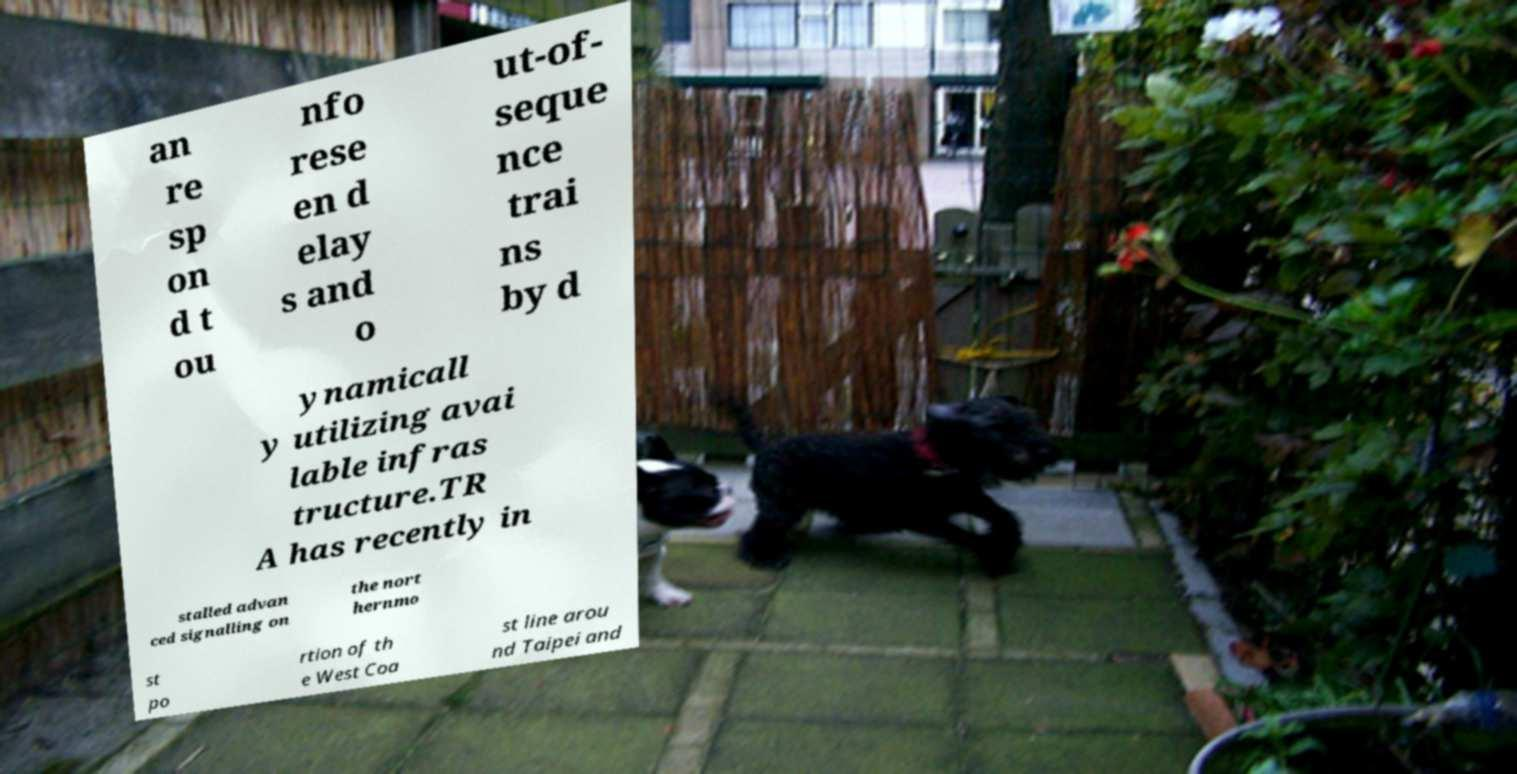Could you extract and type out the text from this image? an re sp on d t ou nfo rese en d elay s and o ut-of- seque nce trai ns by d ynamicall y utilizing avai lable infras tructure.TR A has recently in stalled advan ced signalling on the nort hernmo st po rtion of th e West Coa st line arou nd Taipei and 